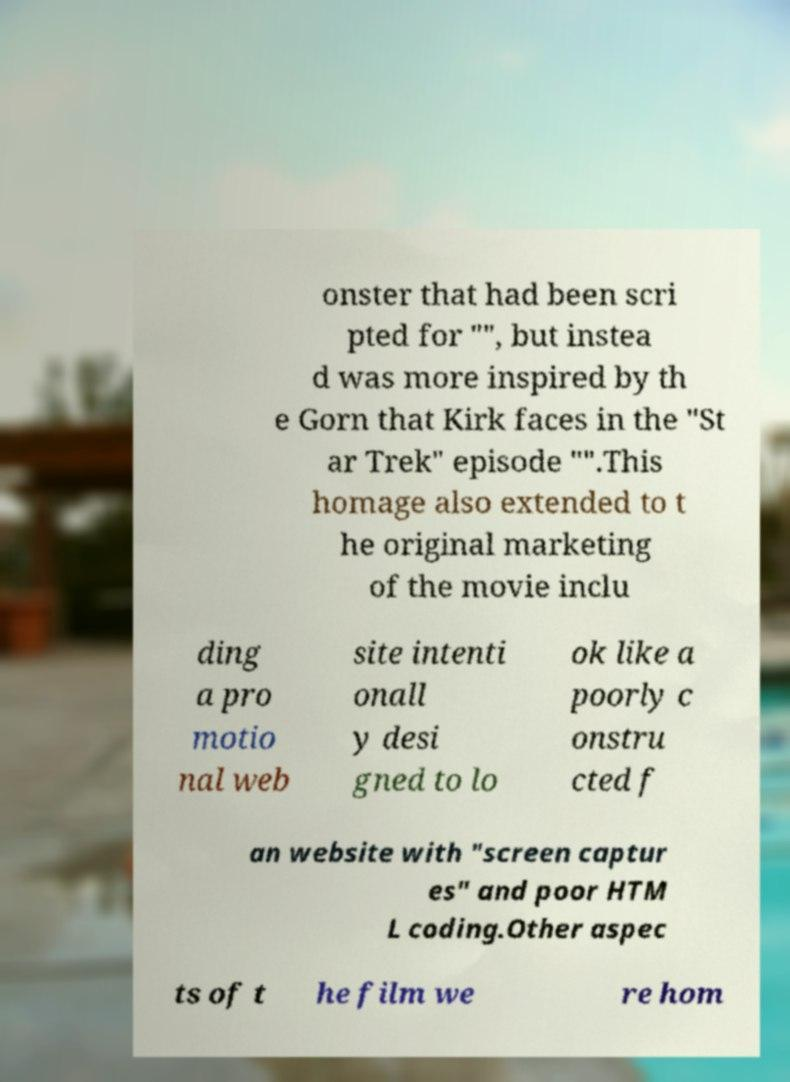What messages or text are displayed in this image? I need them in a readable, typed format. onster that had been scri pted for "", but instea d was more inspired by th e Gorn that Kirk faces in the "St ar Trek" episode "".This homage also extended to t he original marketing of the movie inclu ding a pro motio nal web site intenti onall y desi gned to lo ok like a poorly c onstru cted f an website with "screen captur es" and poor HTM L coding.Other aspec ts of t he film we re hom 